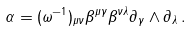<formula> <loc_0><loc_0><loc_500><loc_500>\alpha = ( \omega ^ { - 1 } ) _ { \mu \nu } \beta ^ { \mu \gamma } \beta ^ { \nu \lambda } \partial _ { \gamma } \wedge \partial _ { \lambda } \, .</formula> 